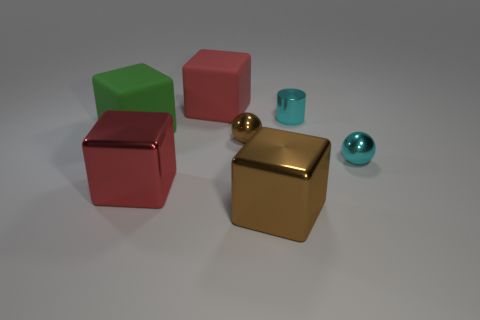There is another shiny object that is the same shape as the red shiny thing; what color is it?
Offer a very short reply. Brown. Is there any other thing that has the same shape as the big red metal thing?
Keep it short and to the point. Yes. Are there the same number of blocks that are right of the large red metal block and big brown shiny things?
Keep it short and to the point. No. What number of blocks are both in front of the metal cylinder and to the right of the green thing?
Provide a succinct answer. 2. There is a cyan object that is the same shape as the small brown thing; what size is it?
Ensure brevity in your answer.  Small. How many small green blocks are the same material as the small cyan sphere?
Offer a terse response. 0. Are there fewer red metallic cubes to the right of the metal cylinder than cyan metal things?
Ensure brevity in your answer.  Yes. What number of tiny spheres are there?
Provide a succinct answer. 2. How many other tiny metal cylinders are the same color as the small cylinder?
Make the answer very short. 0. Is the shape of the large brown shiny thing the same as the green matte thing?
Provide a succinct answer. Yes. 